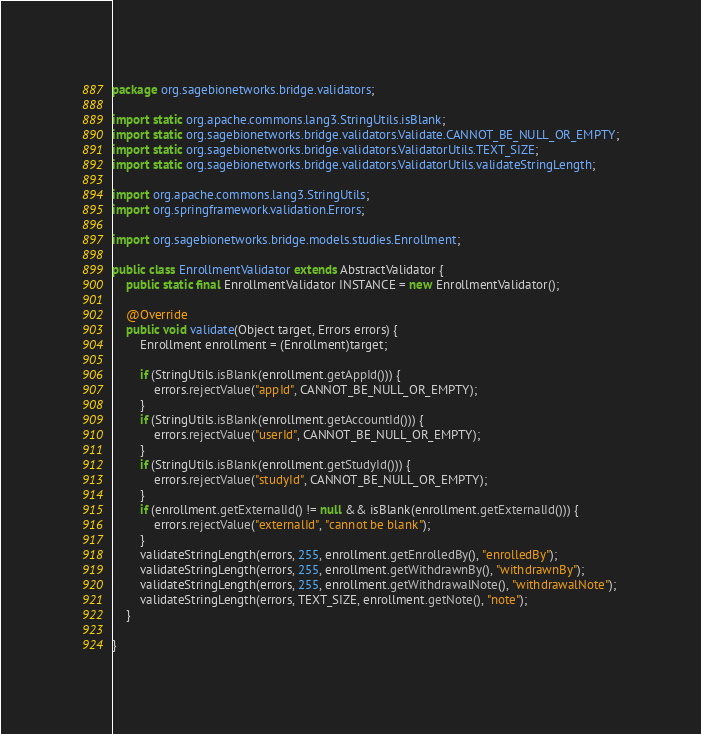Convert code to text. <code><loc_0><loc_0><loc_500><loc_500><_Java_>package org.sagebionetworks.bridge.validators;

import static org.apache.commons.lang3.StringUtils.isBlank;
import static org.sagebionetworks.bridge.validators.Validate.CANNOT_BE_NULL_OR_EMPTY;
import static org.sagebionetworks.bridge.validators.ValidatorUtils.TEXT_SIZE;
import static org.sagebionetworks.bridge.validators.ValidatorUtils.validateStringLength;

import org.apache.commons.lang3.StringUtils;
import org.springframework.validation.Errors;

import org.sagebionetworks.bridge.models.studies.Enrollment;

public class EnrollmentValidator extends AbstractValidator {
    public static final EnrollmentValidator INSTANCE = new EnrollmentValidator();
    
    @Override
    public void validate(Object target, Errors errors) {
        Enrollment enrollment = (Enrollment)target;

        if (StringUtils.isBlank(enrollment.getAppId())) {
            errors.rejectValue("appId", CANNOT_BE_NULL_OR_EMPTY);
        }
        if (StringUtils.isBlank(enrollment.getAccountId())) {
            errors.rejectValue("userId", CANNOT_BE_NULL_OR_EMPTY);
        }
        if (StringUtils.isBlank(enrollment.getStudyId())) {
            errors.rejectValue("studyId", CANNOT_BE_NULL_OR_EMPTY);
        }
        if (enrollment.getExternalId() != null && isBlank(enrollment.getExternalId())) {
            errors.rejectValue("externalId", "cannot be blank");
        }
        validateStringLength(errors, 255, enrollment.getEnrolledBy(), "enrolledBy");
        validateStringLength(errors, 255, enrollment.getWithdrawnBy(), "withdrawnBy");
        validateStringLength(errors, 255, enrollment.getWithdrawalNote(), "withdrawalNote");
        validateStringLength(errors, TEXT_SIZE, enrollment.getNote(), "note");
    }

}
</code> 